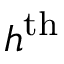<formula> <loc_0><loc_0><loc_500><loc_500>h ^ { t h }</formula> 